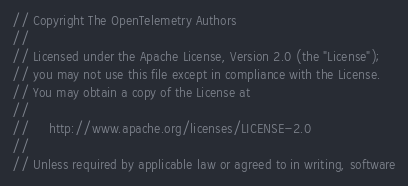Convert code to text. <code><loc_0><loc_0><loc_500><loc_500><_Go_>// Copyright The OpenTelemetry Authors
//
// Licensed under the Apache License, Version 2.0 (the "License");
// you may not use this file except in compliance with the License.
// You may obtain a copy of the License at
//
//     http://www.apache.org/licenses/LICENSE-2.0
//
// Unless required by applicable law or agreed to in writing, software</code> 